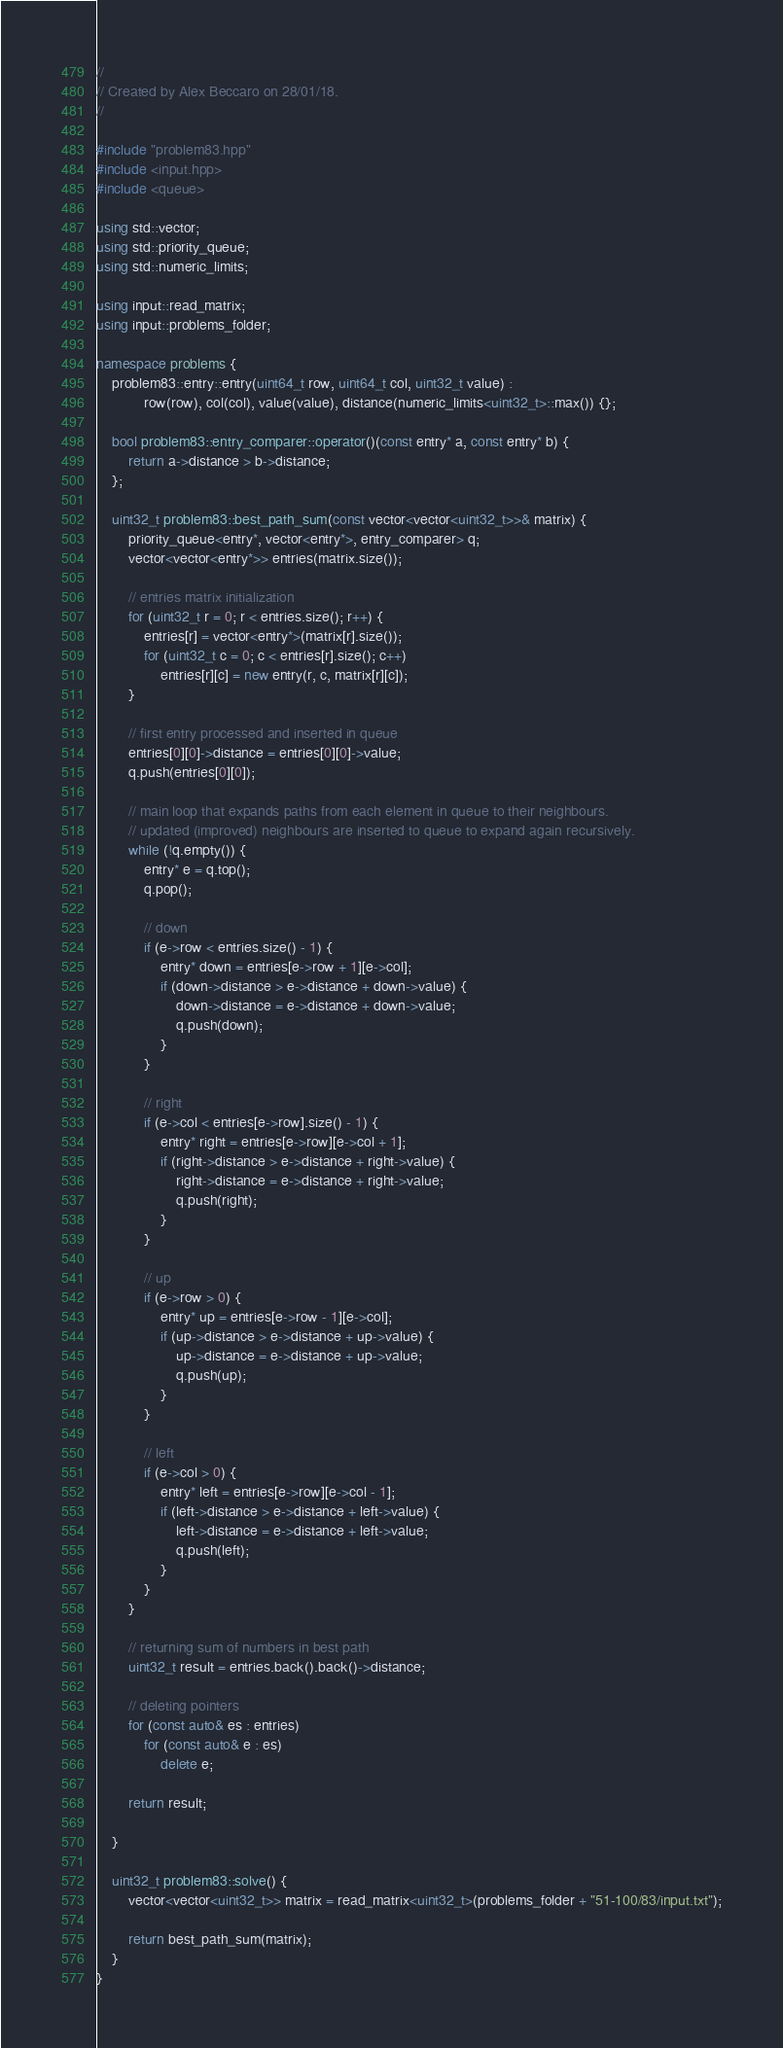Convert code to text. <code><loc_0><loc_0><loc_500><loc_500><_C++_>//
// Created by Alex Beccaro on 28/01/18.
//

#include "problem83.hpp"
#include <input.hpp>
#include <queue>

using std::vector;
using std::priority_queue;
using std::numeric_limits;

using input::read_matrix;
using input::problems_folder;

namespace problems {
    problem83::entry::entry(uint64_t row, uint64_t col, uint32_t value) :
            row(row), col(col), value(value), distance(numeric_limits<uint32_t>::max()) {};

    bool problem83::entry_comparer::operator()(const entry* a, const entry* b) {
        return a->distance > b->distance;
    };

    uint32_t problem83::best_path_sum(const vector<vector<uint32_t>>& matrix) {
        priority_queue<entry*, vector<entry*>, entry_comparer> q;
        vector<vector<entry*>> entries(matrix.size());

        // entries matrix initialization
        for (uint32_t r = 0; r < entries.size(); r++) {
            entries[r] = vector<entry*>(matrix[r].size());
            for (uint32_t c = 0; c < entries[r].size(); c++)
                entries[r][c] = new entry(r, c, matrix[r][c]);
        }

        // first entry processed and inserted in queue
        entries[0][0]->distance = entries[0][0]->value;
        q.push(entries[0][0]);

        // main loop that expands paths from each element in queue to their neighbours.
        // updated (improved) neighbours are inserted to queue to expand again recursively.
        while (!q.empty()) {
            entry* e = q.top();
            q.pop();

            // down
            if (e->row < entries.size() - 1) {
                entry* down = entries[e->row + 1][e->col];
                if (down->distance > e->distance + down->value) {
                    down->distance = e->distance + down->value;
                    q.push(down);
                }
            }

            // right
            if (e->col < entries[e->row].size() - 1) {
                entry* right = entries[e->row][e->col + 1];
                if (right->distance > e->distance + right->value) {
                    right->distance = e->distance + right->value;
                    q.push(right);
                }
            }

            // up
            if (e->row > 0) {
                entry* up = entries[e->row - 1][e->col];
                if (up->distance > e->distance + up->value) {
                    up->distance = e->distance + up->value;
                    q.push(up);
                }
            }

            // left
            if (e->col > 0) {
                entry* left = entries[e->row][e->col - 1];
                if (left->distance > e->distance + left->value) {
                    left->distance = e->distance + left->value;
                    q.push(left);
                }
            }
        }

        // returning sum of numbers in best path
        uint32_t result = entries.back().back()->distance;

        // deleting pointers
        for (const auto& es : entries)
            for (const auto& e : es)
                delete e;

        return result;

    }

    uint32_t problem83::solve() {
        vector<vector<uint32_t>> matrix = read_matrix<uint32_t>(problems_folder + "51-100/83/input.txt");

        return best_path_sum(matrix);
    }
}</code> 